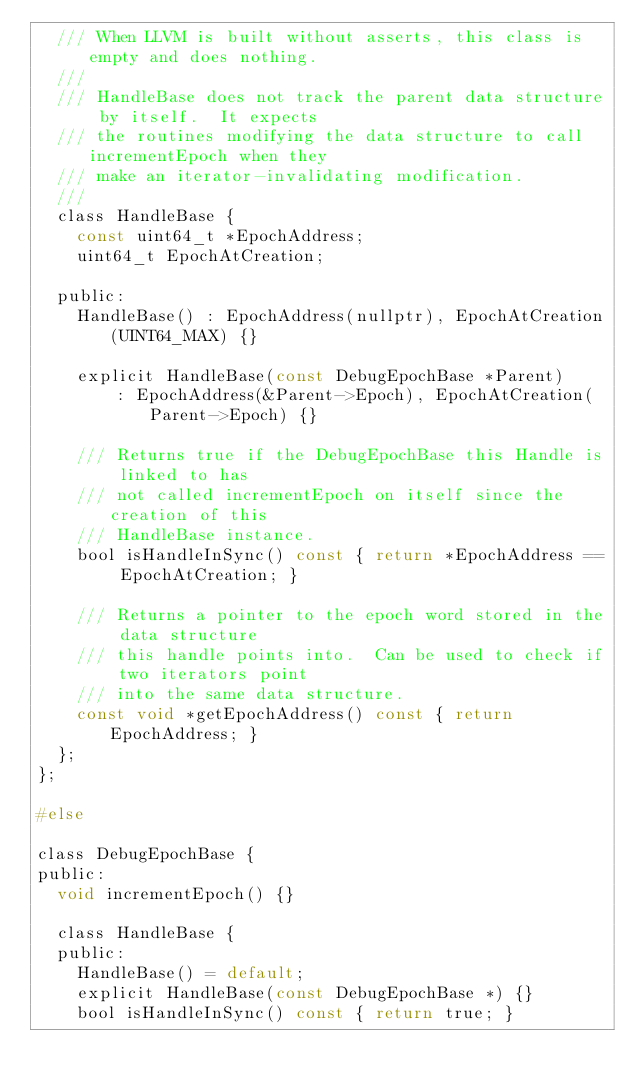Convert code to text. <code><loc_0><loc_0><loc_500><loc_500><_C_>  /// When LLVM is built without asserts, this class is empty and does nothing.
  ///
  /// HandleBase does not track the parent data structure by itself.  It expects
  /// the routines modifying the data structure to call incrementEpoch when they
  /// make an iterator-invalidating modification.
  ///
  class HandleBase {
    const uint64_t *EpochAddress;
    uint64_t EpochAtCreation;

  public:
    HandleBase() : EpochAddress(nullptr), EpochAtCreation(UINT64_MAX) {}

    explicit HandleBase(const DebugEpochBase *Parent)
        : EpochAddress(&Parent->Epoch), EpochAtCreation(Parent->Epoch) {}

    /// Returns true if the DebugEpochBase this Handle is linked to has
    /// not called incrementEpoch on itself since the creation of this
    /// HandleBase instance.
    bool isHandleInSync() const { return *EpochAddress == EpochAtCreation; }

    /// Returns a pointer to the epoch word stored in the data structure
    /// this handle points into.  Can be used to check if two iterators point
    /// into the same data structure.
    const void *getEpochAddress() const { return EpochAddress; }
  };
};

#else

class DebugEpochBase {
public:
  void incrementEpoch() {}

  class HandleBase {
  public:
    HandleBase() = default;
    explicit HandleBase(const DebugEpochBase *) {}
    bool isHandleInSync() const { return true; }</code> 